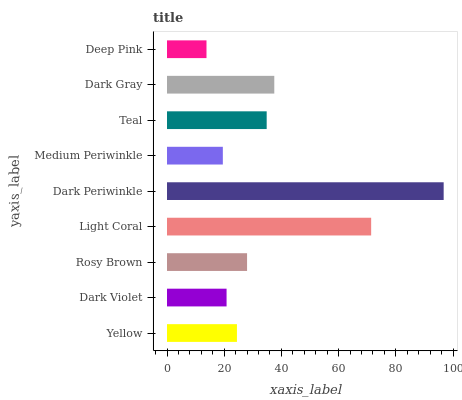Is Deep Pink the minimum?
Answer yes or no. Yes. Is Dark Periwinkle the maximum?
Answer yes or no. Yes. Is Dark Violet the minimum?
Answer yes or no. No. Is Dark Violet the maximum?
Answer yes or no. No. Is Yellow greater than Dark Violet?
Answer yes or no. Yes. Is Dark Violet less than Yellow?
Answer yes or no. Yes. Is Dark Violet greater than Yellow?
Answer yes or no. No. Is Yellow less than Dark Violet?
Answer yes or no. No. Is Rosy Brown the high median?
Answer yes or no. Yes. Is Rosy Brown the low median?
Answer yes or no. Yes. Is Yellow the high median?
Answer yes or no. No. Is Dark Gray the low median?
Answer yes or no. No. 